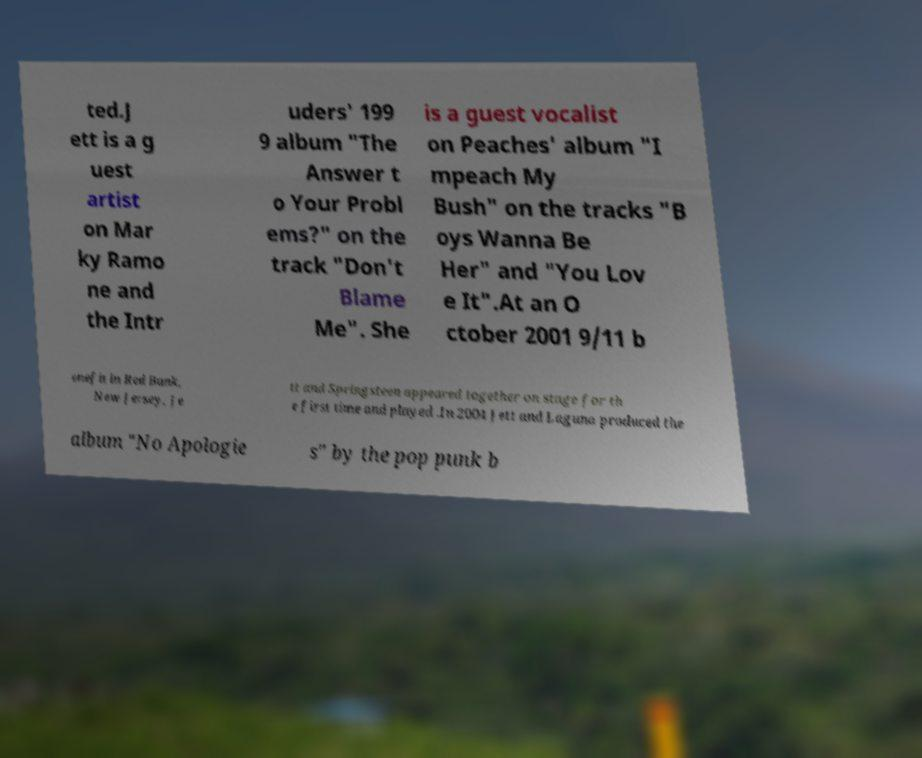Please identify and transcribe the text found in this image. ted.J ett is a g uest artist on Mar ky Ramo ne and the Intr uders' 199 9 album "The Answer t o Your Probl ems?" on the track "Don't Blame Me". She is a guest vocalist on Peaches' album "I mpeach My Bush" on the tracks "B oys Wanna Be Her" and "You Lov e It".At an O ctober 2001 9/11 b enefit in Red Bank, New Jersey, Je tt and Springsteen appeared together on stage for th e first time and played .In 2004 Jett and Laguna produced the album "No Apologie s" by the pop punk b 